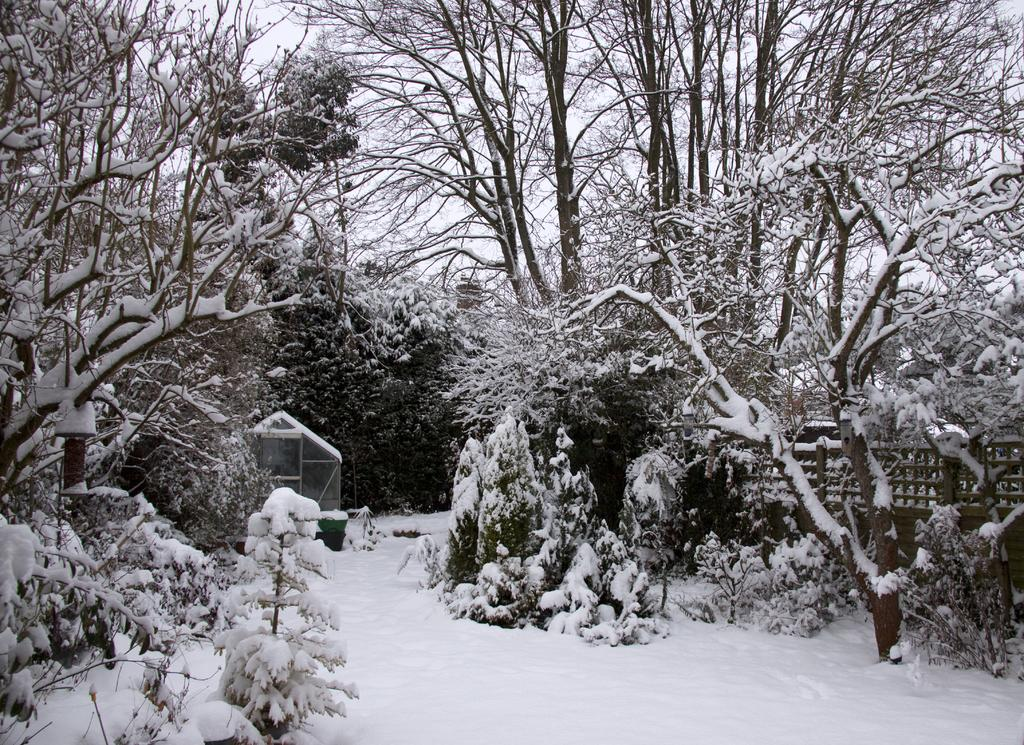What type of vegetation can be seen in the image? There are trees in the image. What structure is present in the image? There is a shelter in the image. What can be used to support or protect in the image? There is a railing in the image. What is the weather like in the image? There is snow visible in the image, suggesting a cold or wintry environment. What else can be seen in the image besides the trees and shelter? There are objects in the image. What is visible in the background of the image? The sky is visible through the trees in the image. What type of flower can be smelled in the image? There is no flower present in the image, so it is not possible to determine its scent. What is the weight of the snow in the image? The weight of the snow cannot be determined from the image alone, as it depends on factors such as temperature and humidity. 